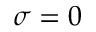<formula> <loc_0><loc_0><loc_500><loc_500>\sigma = 0</formula> 